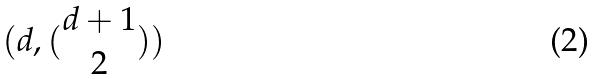Convert formula to latex. <formula><loc_0><loc_0><loc_500><loc_500>( d , ( \begin{matrix} d + 1 \\ 2 \end{matrix} ) )</formula> 